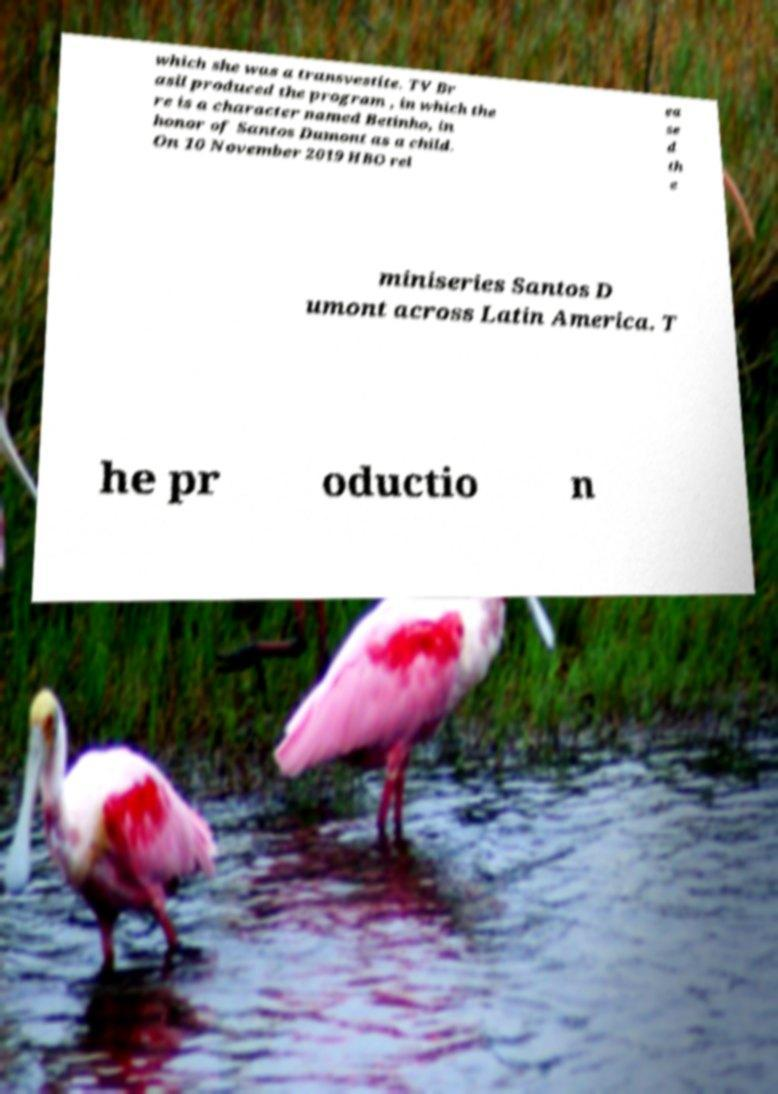Please read and relay the text visible in this image. What does it say? which she was a transvestite. TV Br asil produced the program , in which the re is a character named Betinho, in honor of Santos Dumont as a child. On 10 November 2019 HBO rel ea se d th e miniseries Santos D umont across Latin America. T he pr oductio n 